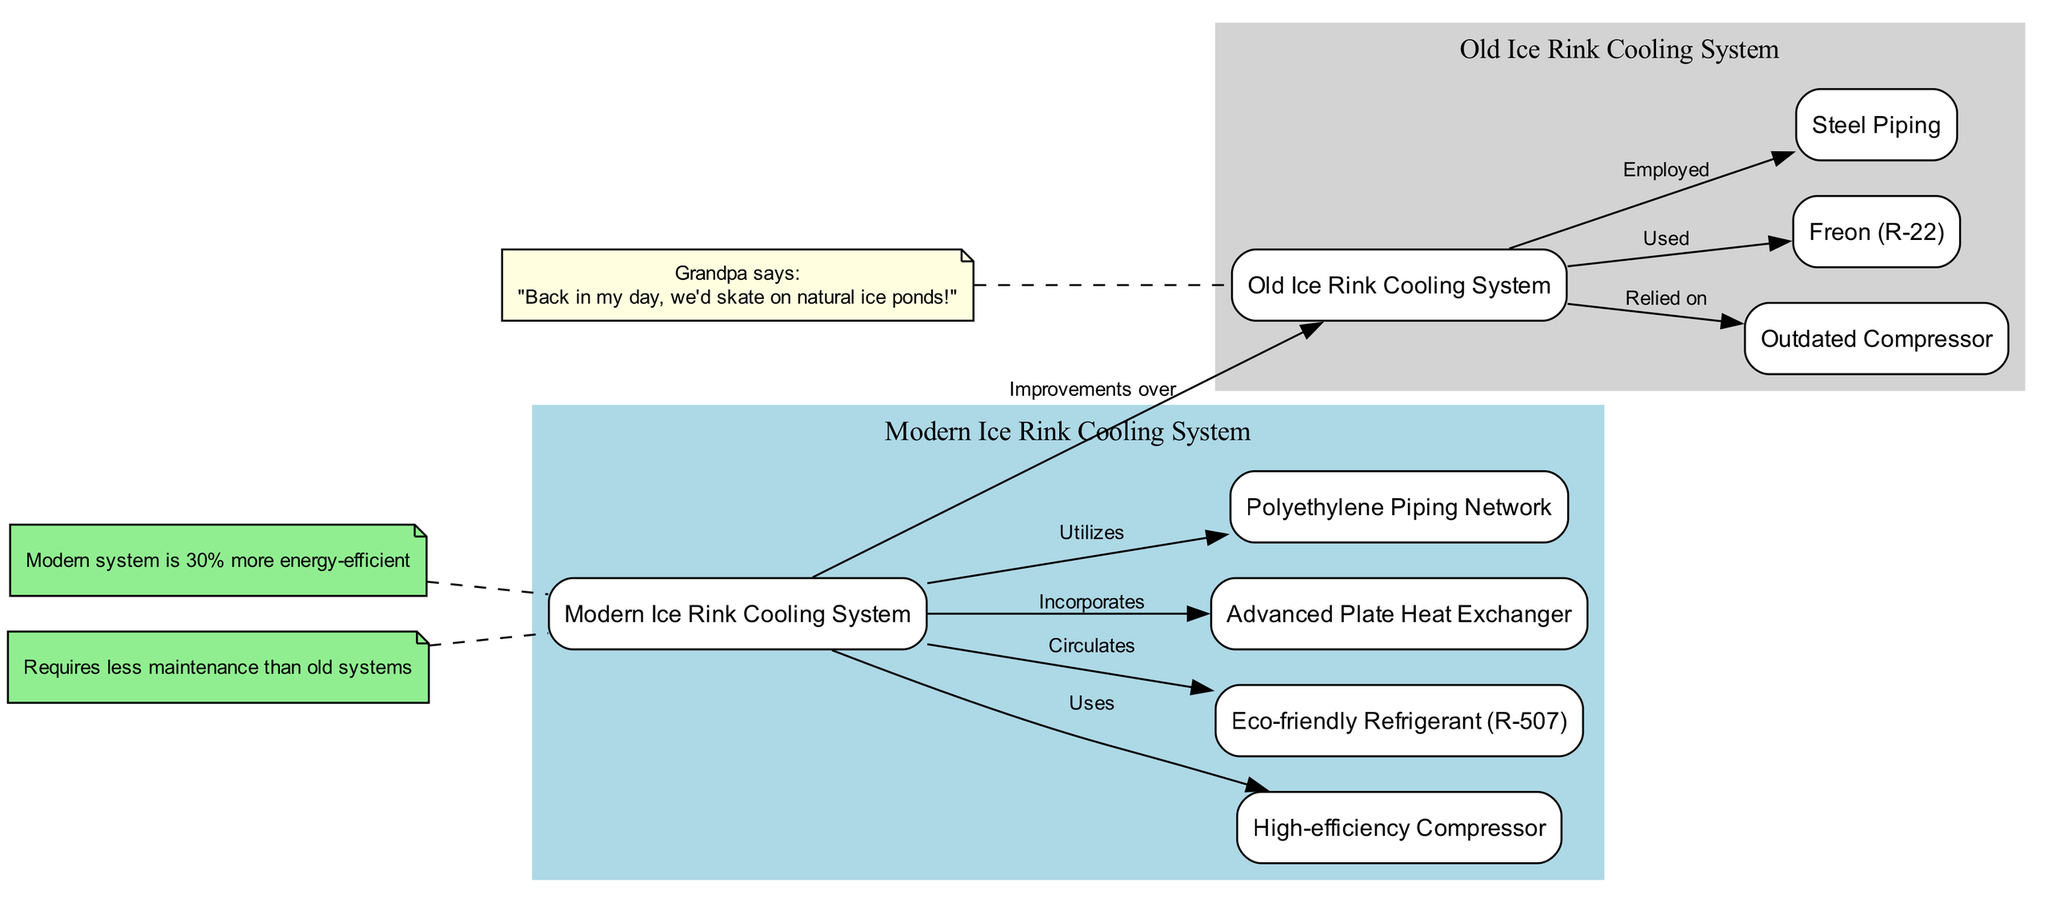What is the modern ice rink cooling system labeled as? The diagram labels the modern ice rink cooling system as "Modern Ice Rink Cooling System." This can be identified at the left side of the diagram where the title of the cluster is prominently displayed.
Answer: Modern Ice Rink Cooling System Which refrigerant is used in the modern system? From the diagram, the modern system circulates an "Eco-friendly Refrigerant (R-507)" which is clearly indicated as a connection from the modern system node to the refrigerant node.
Answer: Eco-friendly Refrigerant (R-507) How much more energy-efficient is the modern cooling system compared to the old system? The note labeled "efficiency_note" states that the modern system is "30% more energy-efficient." This information helps in comparing the performance efficiency of the two systems.
Answer: 30% What component did the old ice rink cooling system rely on? The old system is connected to the node labeled "Outdated Compressor," indicating that it relied upon this specific component. This can be traced along the arrow that signifies reliance on this compressor.
Answer: Outdated Compressor What type of piping does the modern cooling system utilize? The diagram shows that the modern ice rink cooling system utilizes a "Polyethylene Piping Network" indicated with a direct connection from the modern system to the piping node.
Answer: Polyethylene Piping Network Which refrigerant was used in the old ice rink cooling system? The refrigerant used in the old ice rink cooling system is labeled as "Freon (R-22)" in the diagram. This is indicated by the connection from the old system to the refrigerant node.
Answer: Freon (R-22) What unique feature does the modern system incorporate that the old system does not? The modern system incorporates an "Advanced Plate Heat Exchanger," which is specifically mentioned in the diagram as a feature that is connected to the modern system but does not have any equivalent in the old system section.
Answer: Advanced Plate Heat Exchanger Which system employs steel piping? The old ice rink cooling system is indicated to employ "Steel Piping," shown through the connection in the diagram from the old system to the piping node.
Answer: Steel Piping What relationship exists between the modern and old systems? The modern system is indicated to have "Improvements over" the old system, as represented by the connection arrow stating this relationship in the diagram.
Answer: Improvements over 